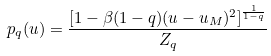Convert formula to latex. <formula><loc_0><loc_0><loc_500><loc_500>p _ { q } ( u ) = \frac { [ 1 - \beta ( 1 - q ) ( u - u _ { M } ) ^ { 2 } ] ^ { \frac { 1 } { 1 - q } } } { Z _ { q } }</formula> 